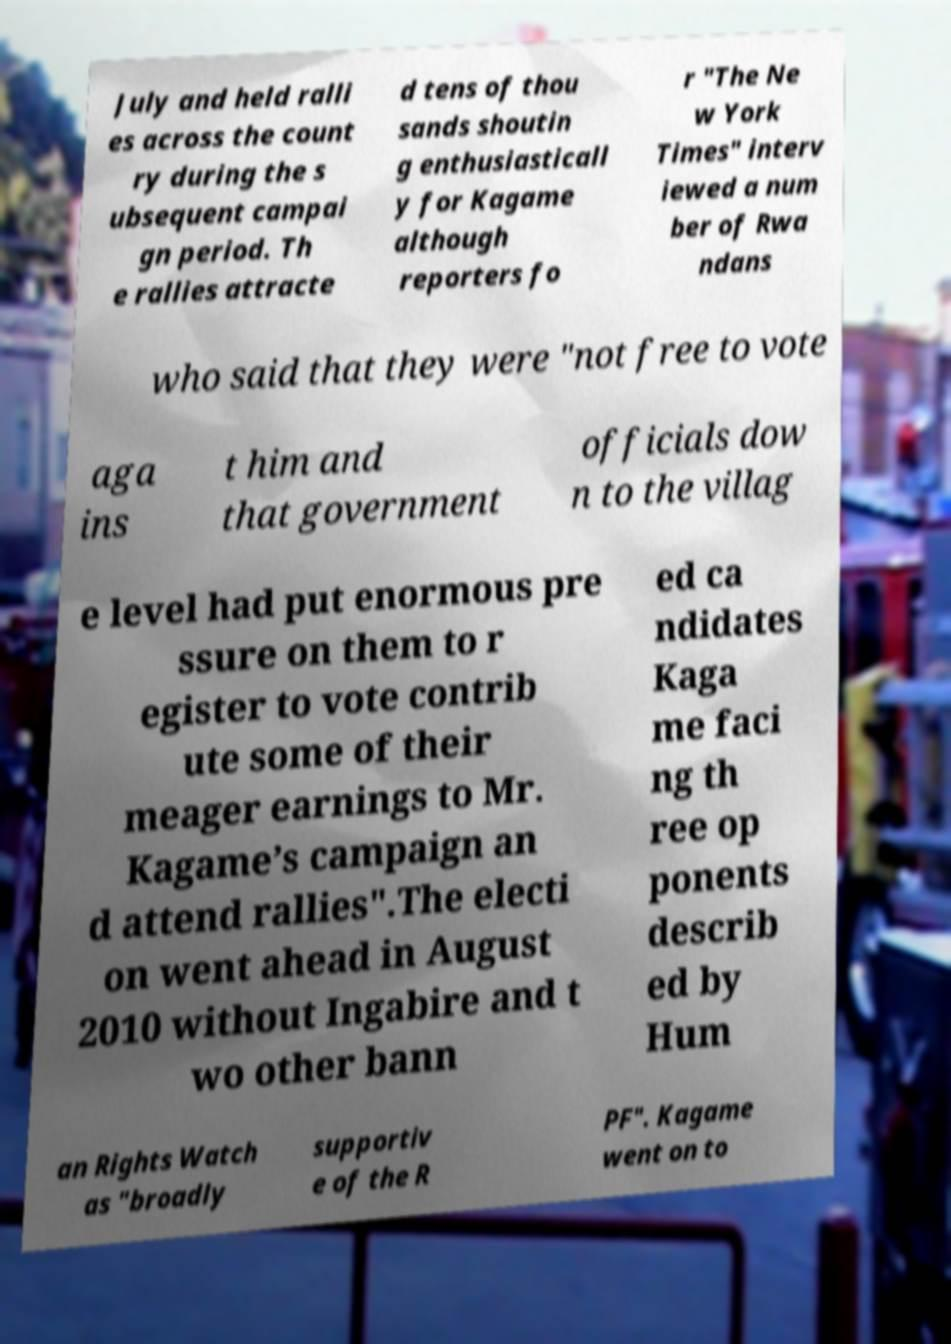I need the written content from this picture converted into text. Can you do that? July and held ralli es across the count ry during the s ubsequent campai gn period. Th e rallies attracte d tens of thou sands shoutin g enthusiasticall y for Kagame although reporters fo r "The Ne w York Times" interv iewed a num ber of Rwa ndans who said that they were "not free to vote aga ins t him and that government officials dow n to the villag e level had put enormous pre ssure on them to r egister to vote contrib ute some of their meager earnings to Mr. Kagame’s campaign an d attend rallies".The electi on went ahead in August 2010 without Ingabire and t wo other bann ed ca ndidates Kaga me faci ng th ree op ponents describ ed by Hum an Rights Watch as "broadly supportiv e of the R PF". Kagame went on to 